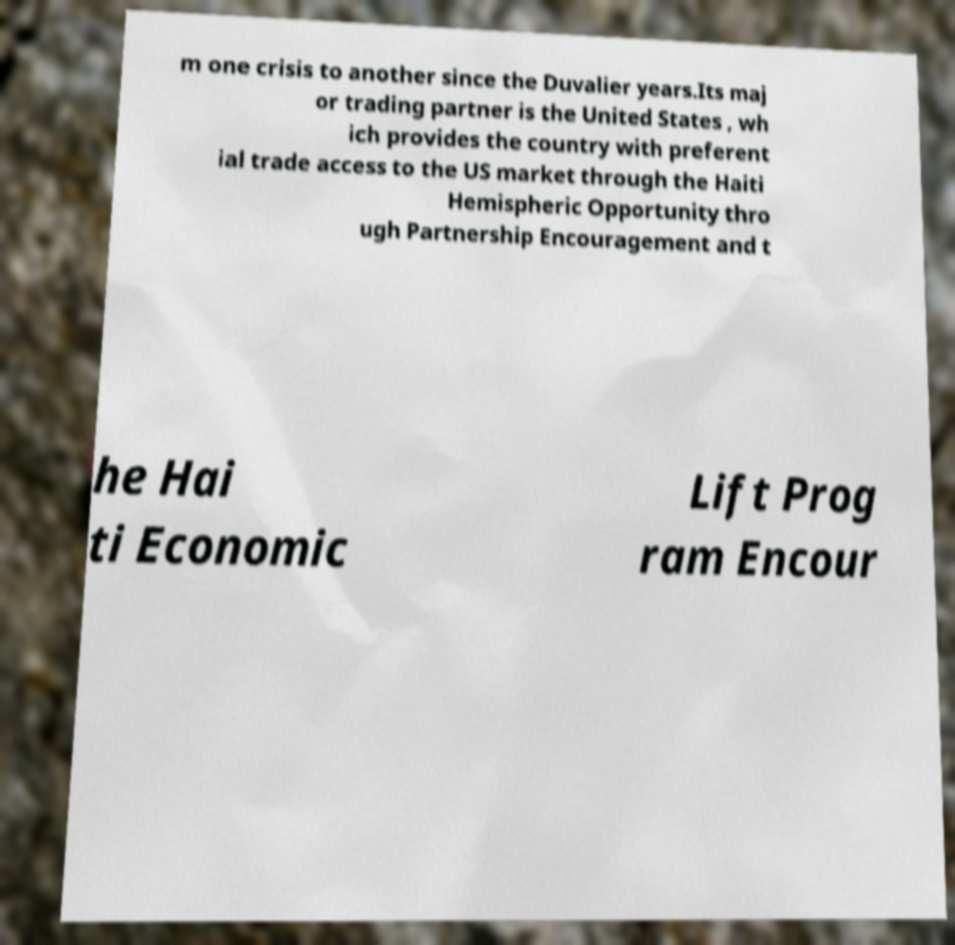What messages or text are displayed in this image? I need them in a readable, typed format. m one crisis to another since the Duvalier years.Its maj or trading partner is the United States , wh ich provides the country with preferent ial trade access to the US market through the Haiti Hemispheric Opportunity thro ugh Partnership Encouragement and t he Hai ti Economic Lift Prog ram Encour 